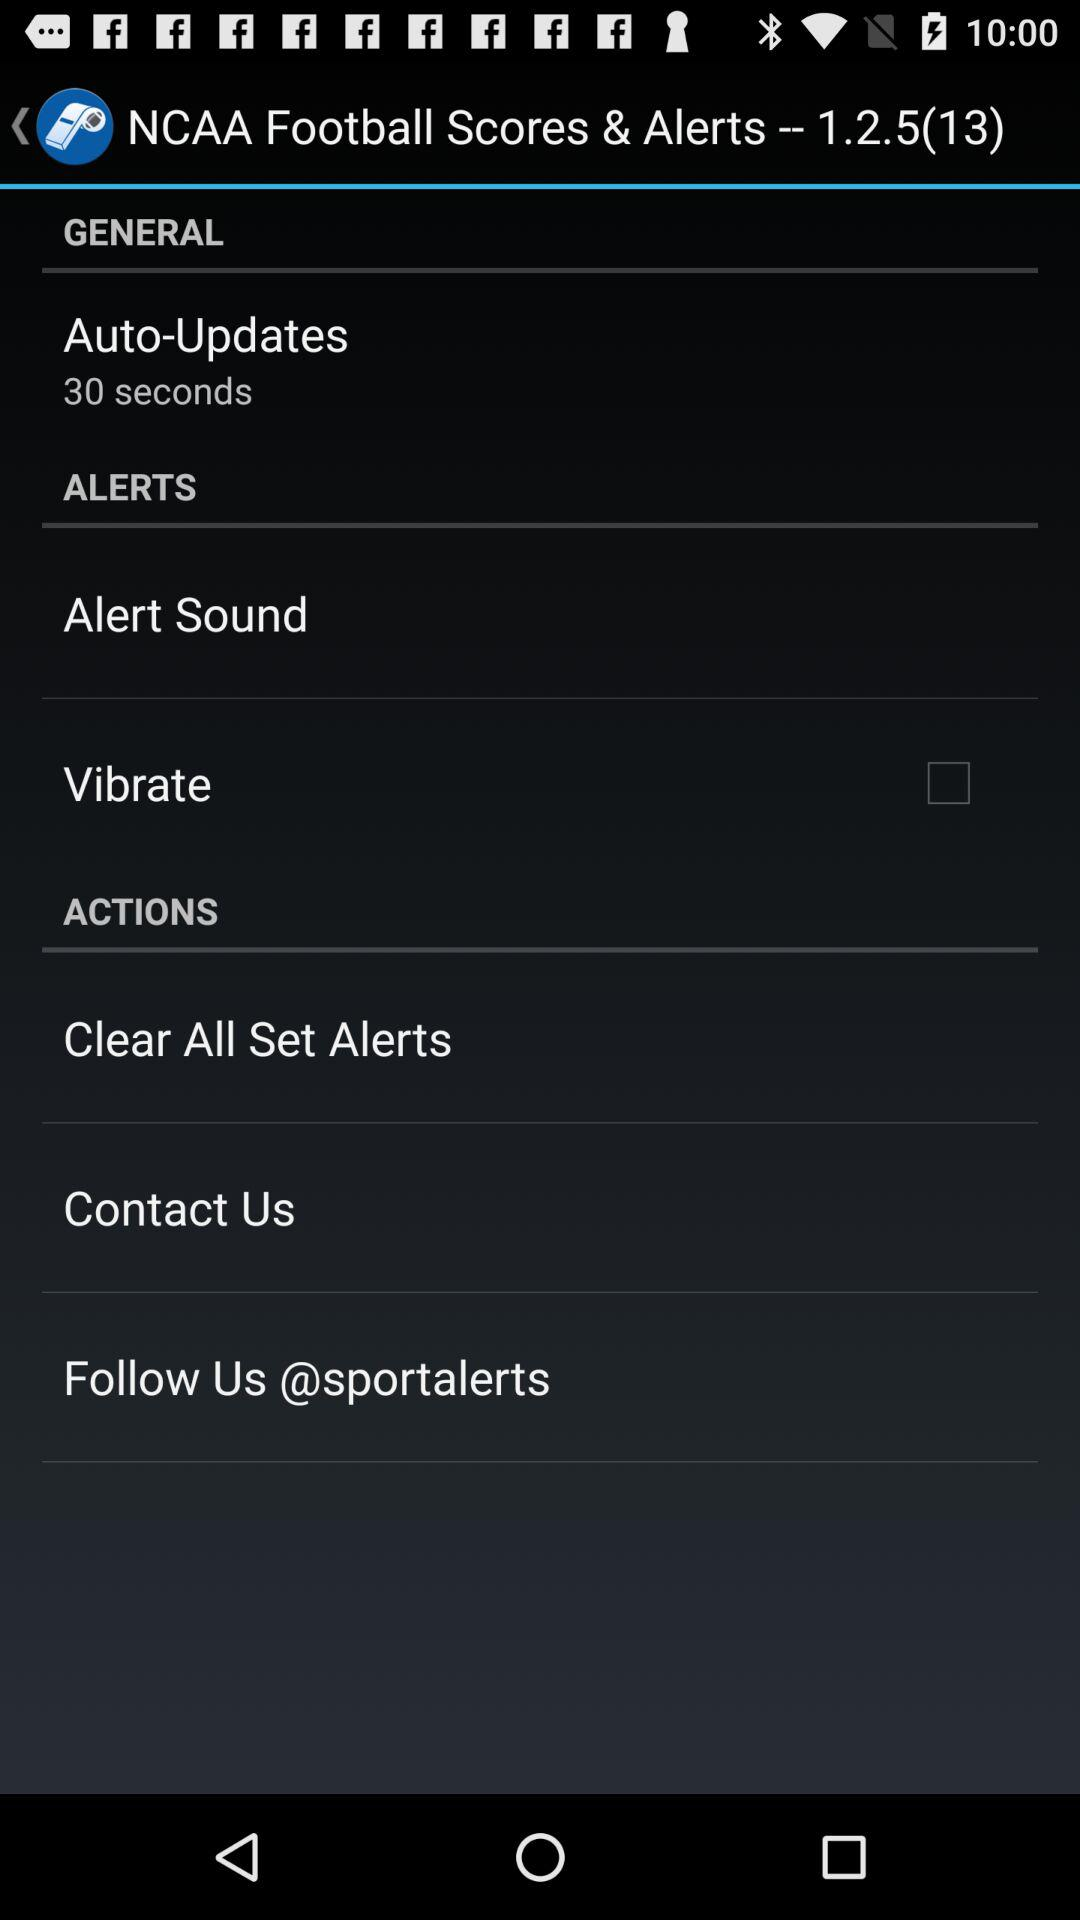What is the time for "Auto-Updates"? The time for "Auto-Updates" is 30 seconds. 